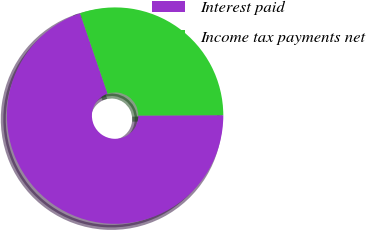<chart> <loc_0><loc_0><loc_500><loc_500><pie_chart><fcel>Interest paid<fcel>Income tax payments net<nl><fcel>69.82%<fcel>30.18%<nl></chart> 